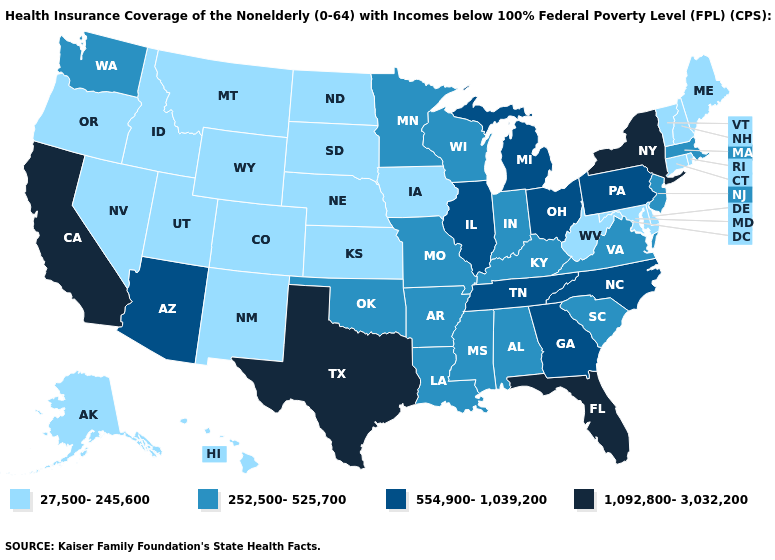Among the states that border Illinois , which have the lowest value?
Short answer required. Iowa. Does West Virginia have a lower value than Kentucky?
Answer briefly. Yes. What is the value of Illinois?
Give a very brief answer. 554,900-1,039,200. Name the states that have a value in the range 1,092,800-3,032,200?
Answer briefly. California, Florida, New York, Texas. Name the states that have a value in the range 27,500-245,600?
Keep it brief. Alaska, Colorado, Connecticut, Delaware, Hawaii, Idaho, Iowa, Kansas, Maine, Maryland, Montana, Nebraska, Nevada, New Hampshire, New Mexico, North Dakota, Oregon, Rhode Island, South Dakota, Utah, Vermont, West Virginia, Wyoming. Which states have the lowest value in the USA?
Quick response, please. Alaska, Colorado, Connecticut, Delaware, Hawaii, Idaho, Iowa, Kansas, Maine, Maryland, Montana, Nebraska, Nevada, New Hampshire, New Mexico, North Dakota, Oregon, Rhode Island, South Dakota, Utah, Vermont, West Virginia, Wyoming. Name the states that have a value in the range 27,500-245,600?
Be succinct. Alaska, Colorado, Connecticut, Delaware, Hawaii, Idaho, Iowa, Kansas, Maine, Maryland, Montana, Nebraska, Nevada, New Hampshire, New Mexico, North Dakota, Oregon, Rhode Island, South Dakota, Utah, Vermont, West Virginia, Wyoming. What is the value of Louisiana?
Give a very brief answer. 252,500-525,700. What is the value of Alabama?
Concise answer only. 252,500-525,700. Name the states that have a value in the range 27,500-245,600?
Quick response, please. Alaska, Colorado, Connecticut, Delaware, Hawaii, Idaho, Iowa, Kansas, Maine, Maryland, Montana, Nebraska, Nevada, New Hampshire, New Mexico, North Dakota, Oregon, Rhode Island, South Dakota, Utah, Vermont, West Virginia, Wyoming. Is the legend a continuous bar?
Give a very brief answer. No. Name the states that have a value in the range 252,500-525,700?
Keep it brief. Alabama, Arkansas, Indiana, Kentucky, Louisiana, Massachusetts, Minnesota, Mississippi, Missouri, New Jersey, Oklahoma, South Carolina, Virginia, Washington, Wisconsin. Name the states that have a value in the range 252,500-525,700?
Write a very short answer. Alabama, Arkansas, Indiana, Kentucky, Louisiana, Massachusetts, Minnesota, Mississippi, Missouri, New Jersey, Oklahoma, South Carolina, Virginia, Washington, Wisconsin. Does Missouri have a higher value than Kansas?
Concise answer only. Yes. What is the highest value in states that border Washington?
Concise answer only. 27,500-245,600. 